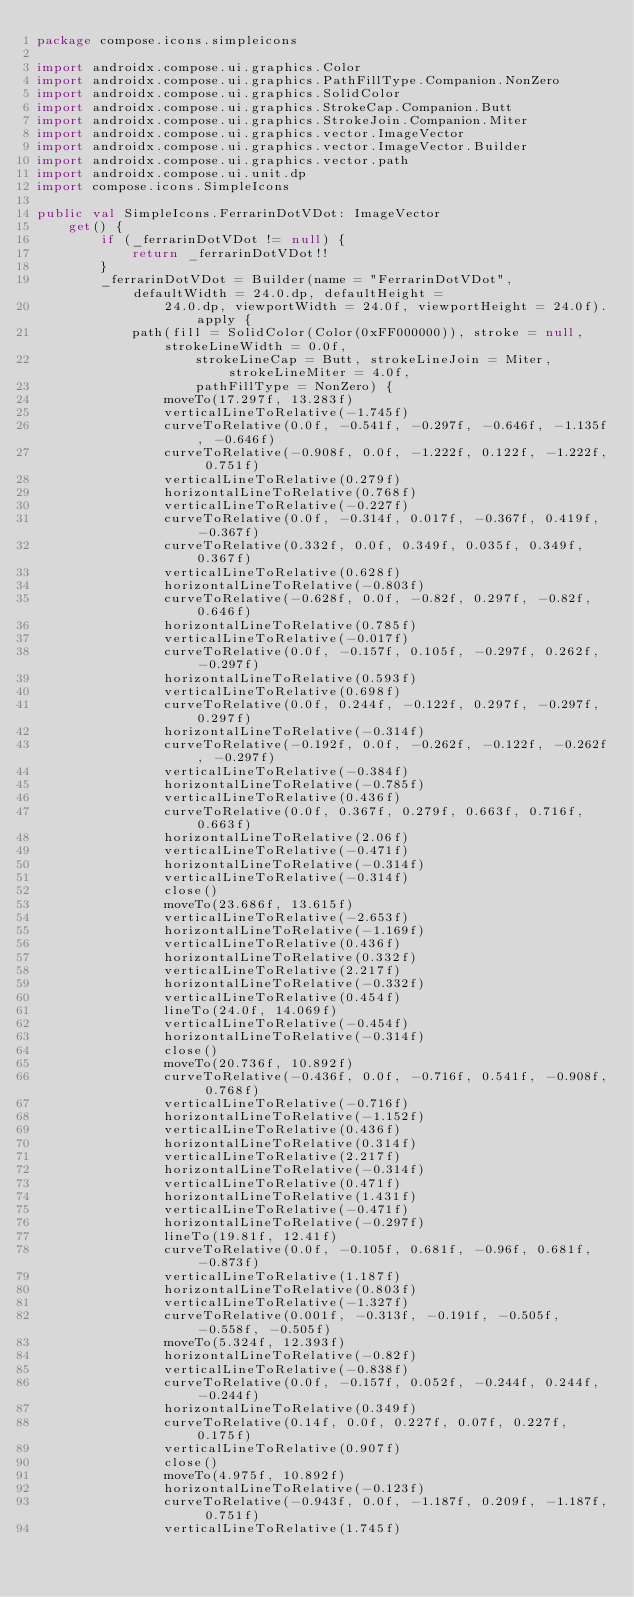<code> <loc_0><loc_0><loc_500><loc_500><_Kotlin_>package compose.icons.simpleicons

import androidx.compose.ui.graphics.Color
import androidx.compose.ui.graphics.PathFillType.Companion.NonZero
import androidx.compose.ui.graphics.SolidColor
import androidx.compose.ui.graphics.StrokeCap.Companion.Butt
import androidx.compose.ui.graphics.StrokeJoin.Companion.Miter
import androidx.compose.ui.graphics.vector.ImageVector
import androidx.compose.ui.graphics.vector.ImageVector.Builder
import androidx.compose.ui.graphics.vector.path
import androidx.compose.ui.unit.dp
import compose.icons.SimpleIcons

public val SimpleIcons.FerrarinDotVDot: ImageVector
    get() {
        if (_ferrarinDotVDot != null) {
            return _ferrarinDotVDot!!
        }
        _ferrarinDotVDot = Builder(name = "FerrarinDotVDot", defaultWidth = 24.0.dp, defaultHeight =
                24.0.dp, viewportWidth = 24.0f, viewportHeight = 24.0f).apply {
            path(fill = SolidColor(Color(0xFF000000)), stroke = null, strokeLineWidth = 0.0f,
                    strokeLineCap = Butt, strokeLineJoin = Miter, strokeLineMiter = 4.0f,
                    pathFillType = NonZero) {
                moveTo(17.297f, 13.283f)
                verticalLineToRelative(-1.745f)
                curveToRelative(0.0f, -0.541f, -0.297f, -0.646f, -1.135f, -0.646f)
                curveToRelative(-0.908f, 0.0f, -1.222f, 0.122f, -1.222f, 0.751f)
                verticalLineToRelative(0.279f)
                horizontalLineToRelative(0.768f)
                verticalLineToRelative(-0.227f)
                curveToRelative(0.0f, -0.314f, 0.017f, -0.367f, 0.419f, -0.367f)
                curveToRelative(0.332f, 0.0f, 0.349f, 0.035f, 0.349f, 0.367f)
                verticalLineToRelative(0.628f)
                horizontalLineToRelative(-0.803f)
                curveToRelative(-0.628f, 0.0f, -0.82f, 0.297f, -0.82f, 0.646f)
                horizontalLineToRelative(0.785f)
                verticalLineToRelative(-0.017f)
                curveToRelative(0.0f, -0.157f, 0.105f, -0.297f, 0.262f, -0.297f)
                horizontalLineToRelative(0.593f)
                verticalLineToRelative(0.698f)
                curveToRelative(0.0f, 0.244f, -0.122f, 0.297f, -0.297f, 0.297f)
                horizontalLineToRelative(-0.314f)
                curveToRelative(-0.192f, 0.0f, -0.262f, -0.122f, -0.262f, -0.297f)
                verticalLineToRelative(-0.384f)
                horizontalLineToRelative(-0.785f)
                verticalLineToRelative(0.436f)
                curveToRelative(0.0f, 0.367f, 0.279f, 0.663f, 0.716f, 0.663f)
                horizontalLineToRelative(2.06f)
                verticalLineToRelative(-0.471f)
                horizontalLineToRelative(-0.314f)
                verticalLineToRelative(-0.314f)
                close()
                moveTo(23.686f, 13.615f)
                verticalLineToRelative(-2.653f)
                horizontalLineToRelative(-1.169f)
                verticalLineToRelative(0.436f)
                horizontalLineToRelative(0.332f)
                verticalLineToRelative(2.217f)
                horizontalLineToRelative(-0.332f)
                verticalLineToRelative(0.454f)
                lineTo(24.0f, 14.069f)
                verticalLineToRelative(-0.454f)
                horizontalLineToRelative(-0.314f)
                close()
                moveTo(20.736f, 10.892f)
                curveToRelative(-0.436f, 0.0f, -0.716f, 0.541f, -0.908f, 0.768f)
                verticalLineToRelative(-0.716f)
                horizontalLineToRelative(-1.152f)
                verticalLineToRelative(0.436f)
                horizontalLineToRelative(0.314f)
                verticalLineToRelative(2.217f)
                horizontalLineToRelative(-0.314f)
                verticalLineToRelative(0.471f)
                horizontalLineToRelative(1.431f)
                verticalLineToRelative(-0.471f)
                horizontalLineToRelative(-0.297f)
                lineTo(19.81f, 12.41f)
                curveToRelative(0.0f, -0.105f, 0.681f, -0.96f, 0.681f, -0.873f)
                verticalLineToRelative(1.187f)
                horizontalLineToRelative(0.803f)
                verticalLineToRelative(-1.327f)
                curveToRelative(0.001f, -0.313f, -0.191f, -0.505f, -0.558f, -0.505f)
                moveTo(5.324f, 12.393f)
                horizontalLineToRelative(-0.82f)
                verticalLineToRelative(-0.838f)
                curveToRelative(0.0f, -0.157f, 0.052f, -0.244f, 0.244f, -0.244f)
                horizontalLineToRelative(0.349f)
                curveToRelative(0.14f, 0.0f, 0.227f, 0.07f, 0.227f, 0.175f)
                verticalLineToRelative(0.907f)
                close()
                moveTo(4.975f, 10.892f)
                horizontalLineToRelative(-0.123f)
                curveToRelative(-0.943f, 0.0f, -1.187f, 0.209f, -1.187f, 0.751f)
                verticalLineToRelative(1.745f)</code> 